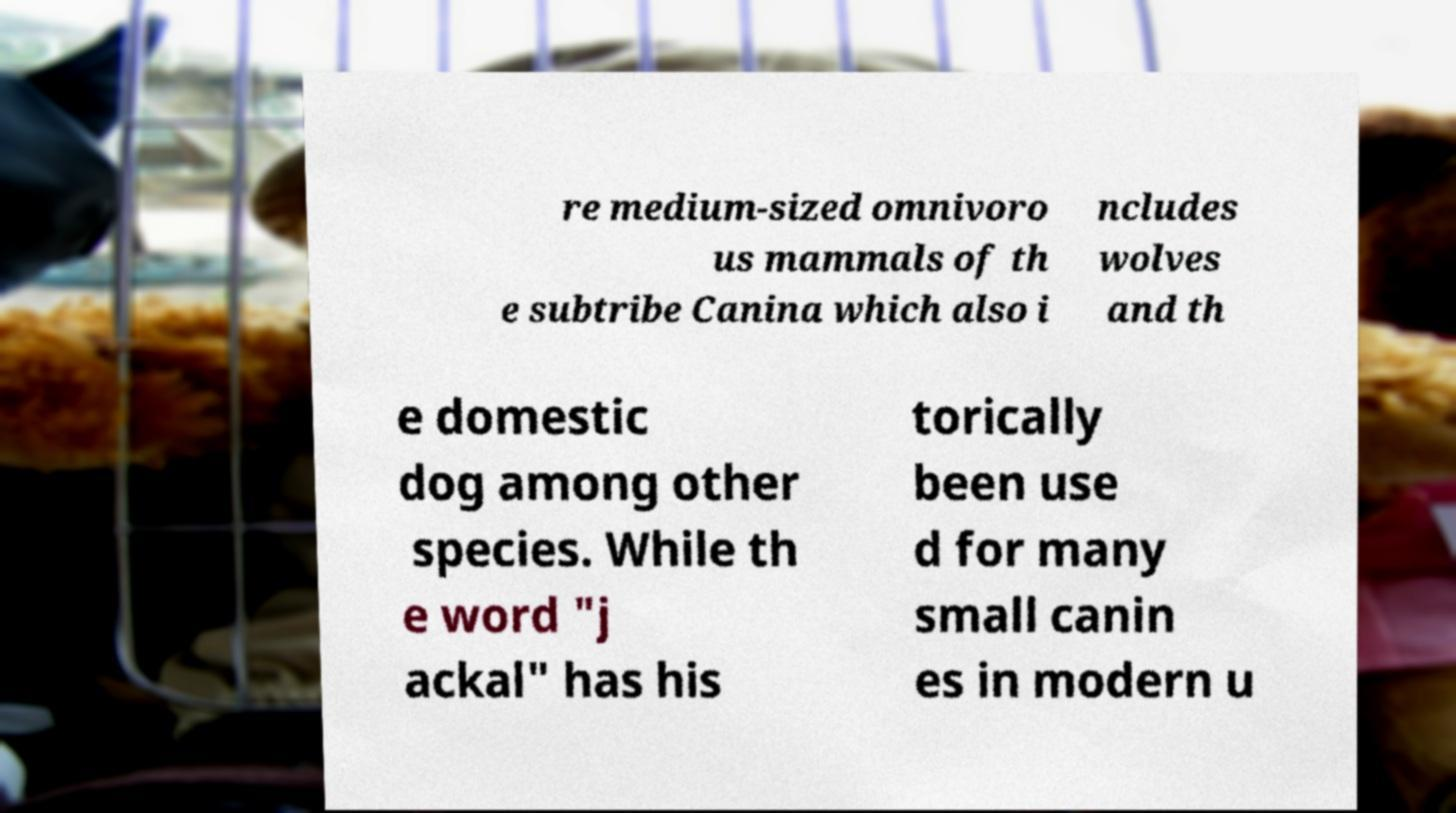For documentation purposes, I need the text within this image transcribed. Could you provide that? re medium-sized omnivoro us mammals of th e subtribe Canina which also i ncludes wolves and th e domestic dog among other species. While th e word "j ackal" has his torically been use d for many small canin es in modern u 